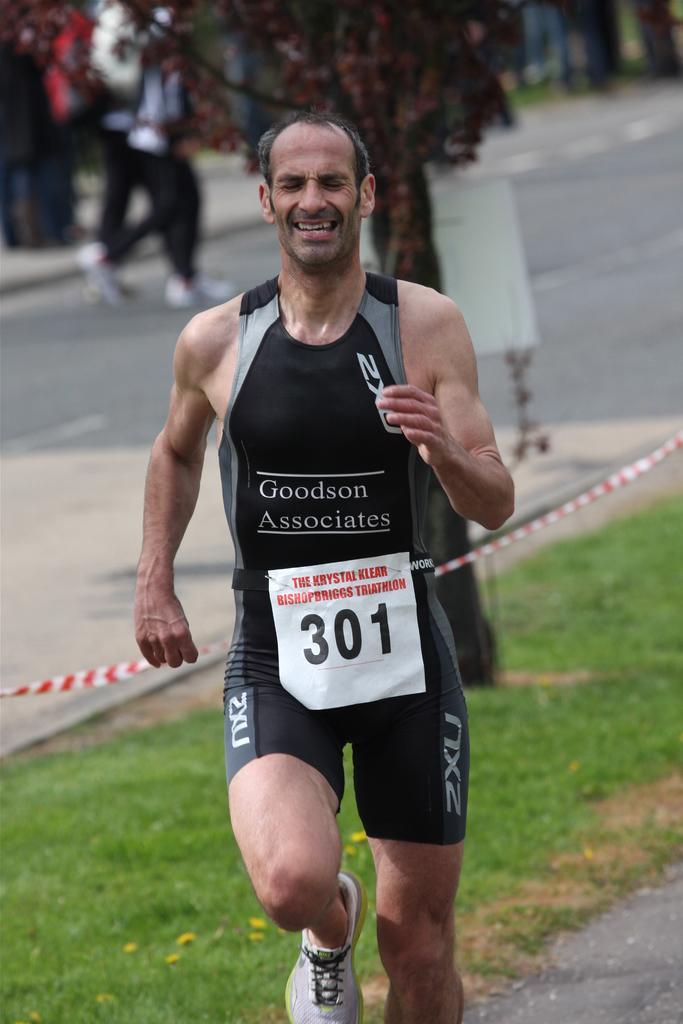<image>
Share a concise interpretation of the image provided. a man running with the number 301 on his chest 